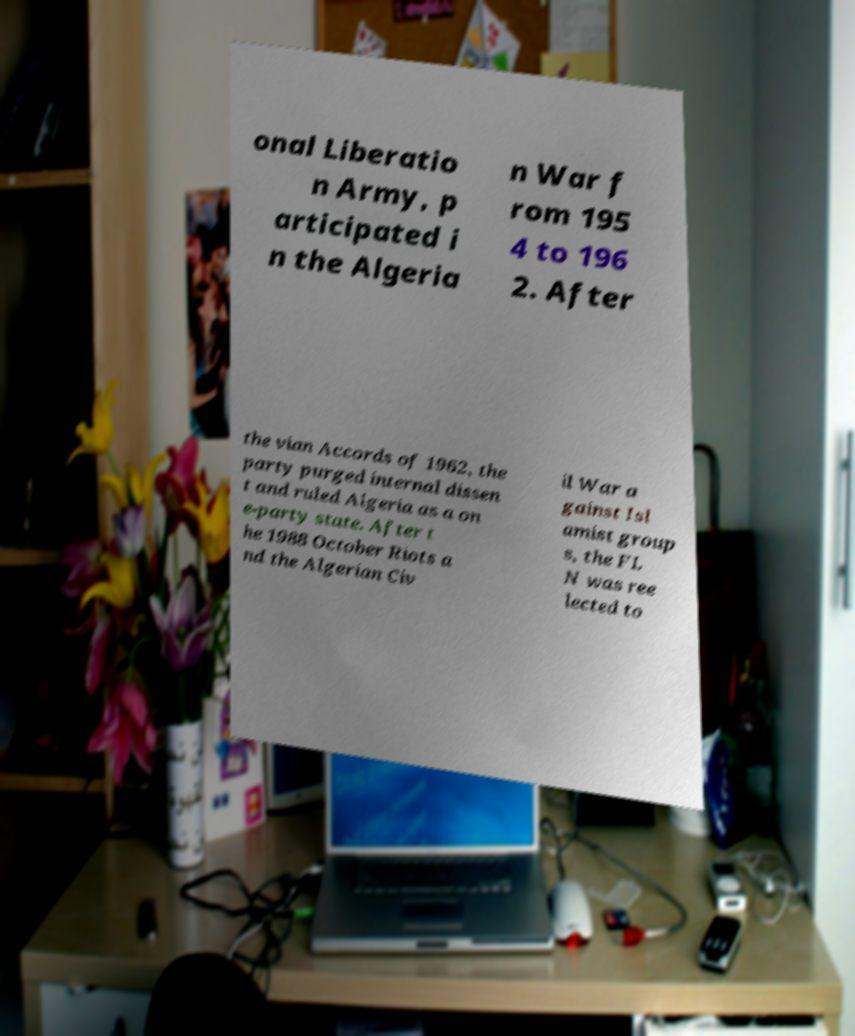Could you extract and type out the text from this image? onal Liberatio n Army, p articipated i n the Algeria n War f rom 195 4 to 196 2. After the vian Accords of 1962, the party purged internal dissen t and ruled Algeria as a on e-party state. After t he 1988 October Riots a nd the Algerian Civ il War a gainst Isl amist group s, the FL N was ree lected to 